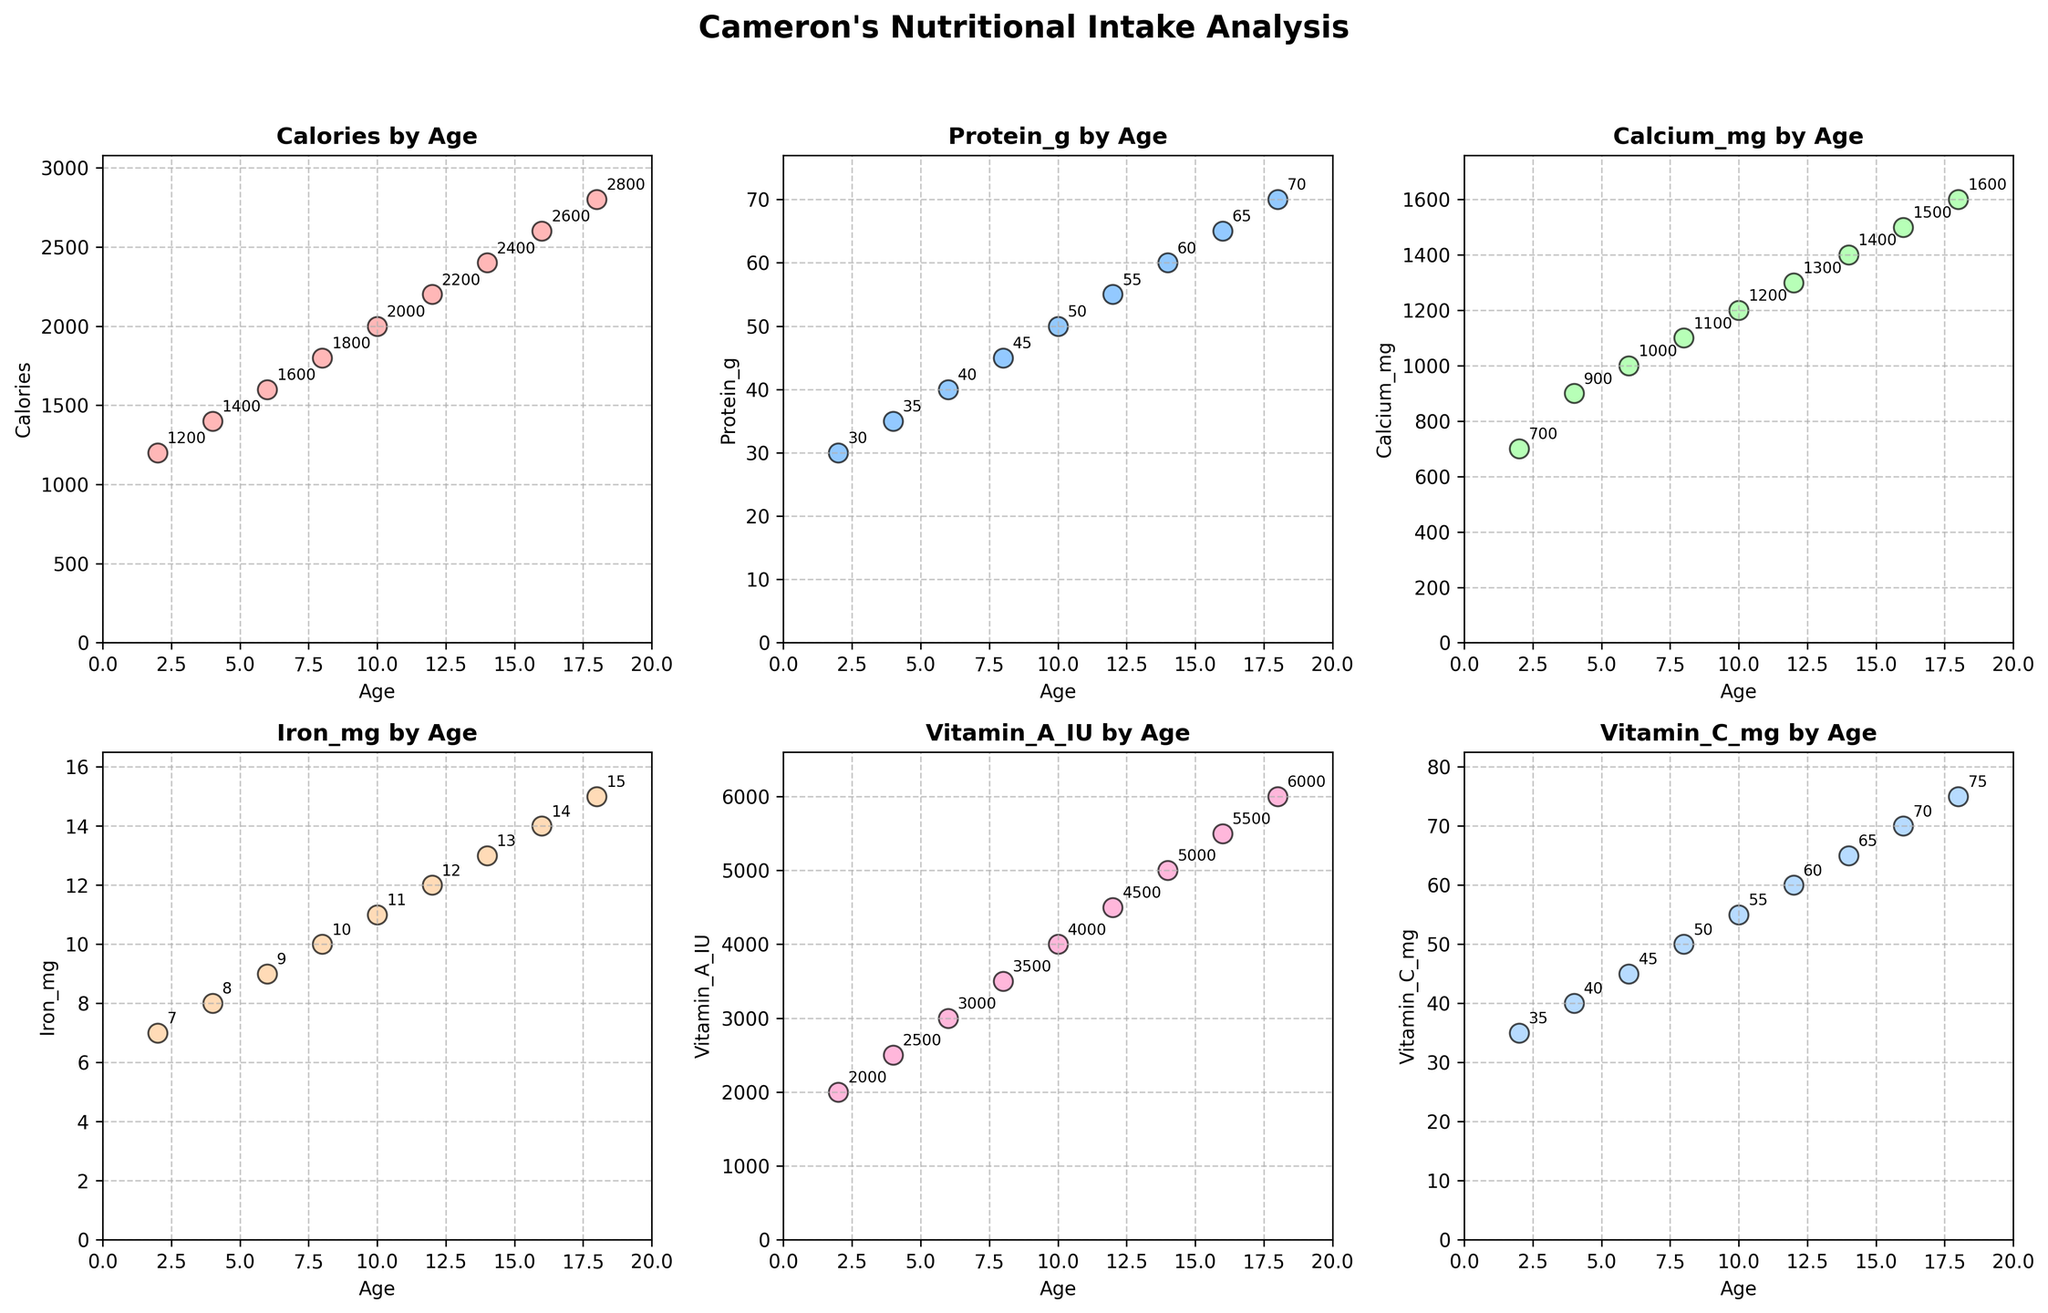What's the title of the figure? The title is displayed prominently at the top of the figure and typically summarizes the content of the entire figure, in this case, it reads "Cameron's Nutritional Intake Analysis".
Answer: Cameron's Nutritional Intake Analysis What are the age ranges shown in the plots? The x-axes of all scatter plots represent the age, and they range from 2 to 18 years old.
Answer: 2 to 18 years old Which plot has the highest data point? By inspecting all six plots, the "Calories by Age" plot contains the highest data point, which is 2800 at age 18.
Answer: Calories by Age How does Vitamin C intake change between ages 12 and 16? In the "Vitamin C by Age" plot, identifying the values at ages 12 and 16 shows that Vitamin C intake increases from 60 mg to 70 mg.
Answer: Increases from 60 mg to 70 mg Which age group consumes the most Calcium? By checking the “Calcium by Age” plot, the highest data point is at age 18, where Calcium intake is 1600 mg.
Answer: Age 18 What's the average protein intake for ages 4, 8, and 12? Locate the data points for "Protein by Age" at ages 4, 8, and 12 which are 35g, 45g, and 55g. Summing these values gives 135g, and the average is 135g / 3 = 45g.
Answer: 45g At what age does Iron intake exceed 10 mg? From the "Iron by Age" plot, the Iron intake exceeds 10 mg starting at age 10.
Answer: Age 10 Compare the Vitamin A intake of ages 6 and 14. Which is higher? In the "Vitamin A by Age" plot, Vitamin A intake at age 6 is 3000 IU, and at age 14 it is 5000 IU. The intake at age 14 is higher.
Answer: Age 14 What trends do you observe in the Calorie consumption by age? Examining the "Calories by Age" plot reveals a steadily increasing trend in Calorie consumption as age increases.
Answer: It steadily increases What is the difference in Calcium intake between age 6 and age 16? On the "Calcium by Age" plot, Calcium intake is 1000 mg at age 6 and 1500 mg at age 16. The difference is 1500 mg - 1000 mg = 500 mg.
Answer: 500 mg 